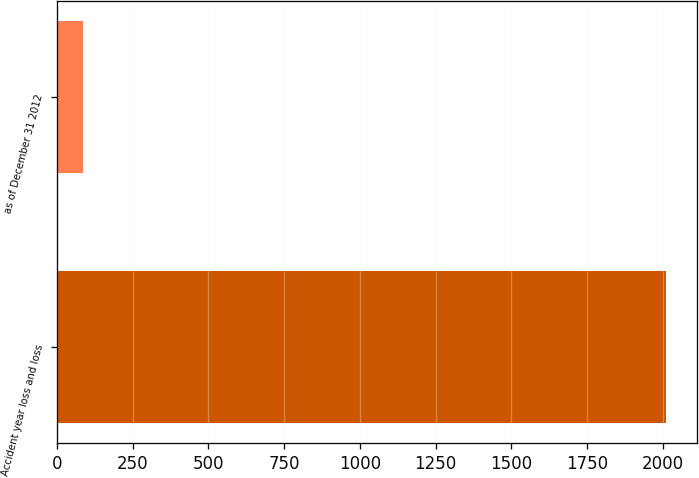Convert chart to OTSL. <chart><loc_0><loc_0><loc_500><loc_500><bar_chart><fcel>Accident year loss and loss<fcel>as of December 31 2012<nl><fcel>2012<fcel>85.4<nl></chart> 